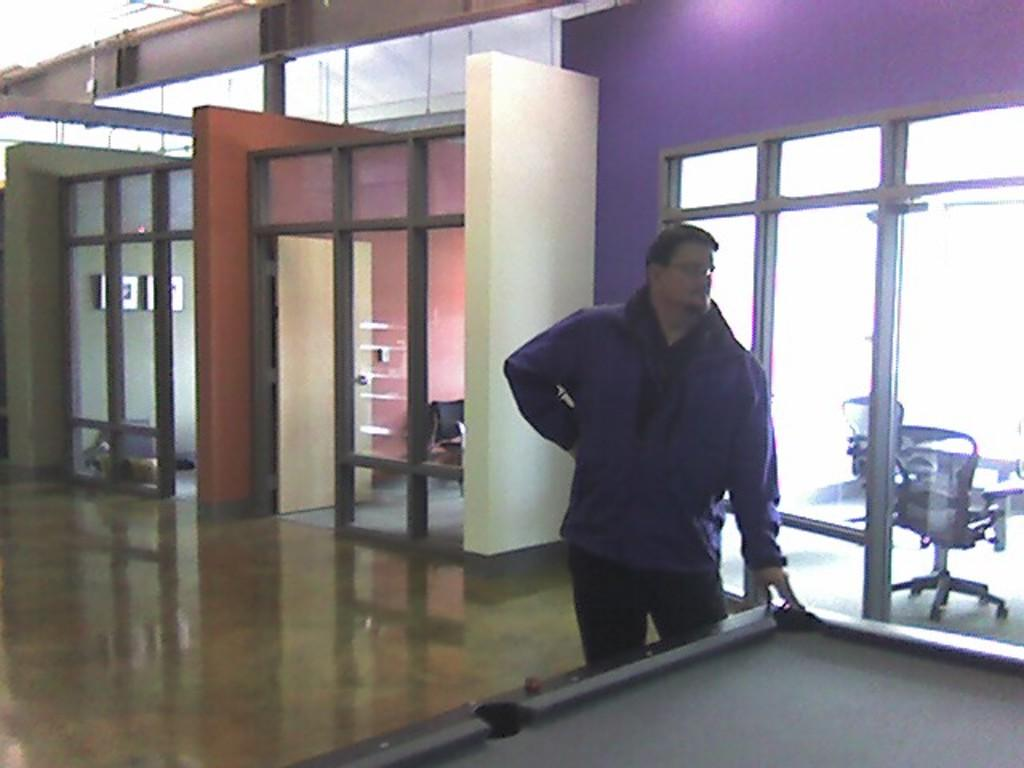What is the main subject of the image? There is a person in the image. What is the person wearing? The person is wearing a violet dress. What is the person doing in the image? The person is standing and has placed their hand on a table. Can you describe any architectural features in the image? Yes, there is a glass door in the image. What type of veil is the person wearing in the image? There is no veil present in the image; the person is wearing a violet dress. What is being served for dinner in the image? There is no dinner or food being served in the image; it primarily features a person standing near a table with a glass door in the background. 